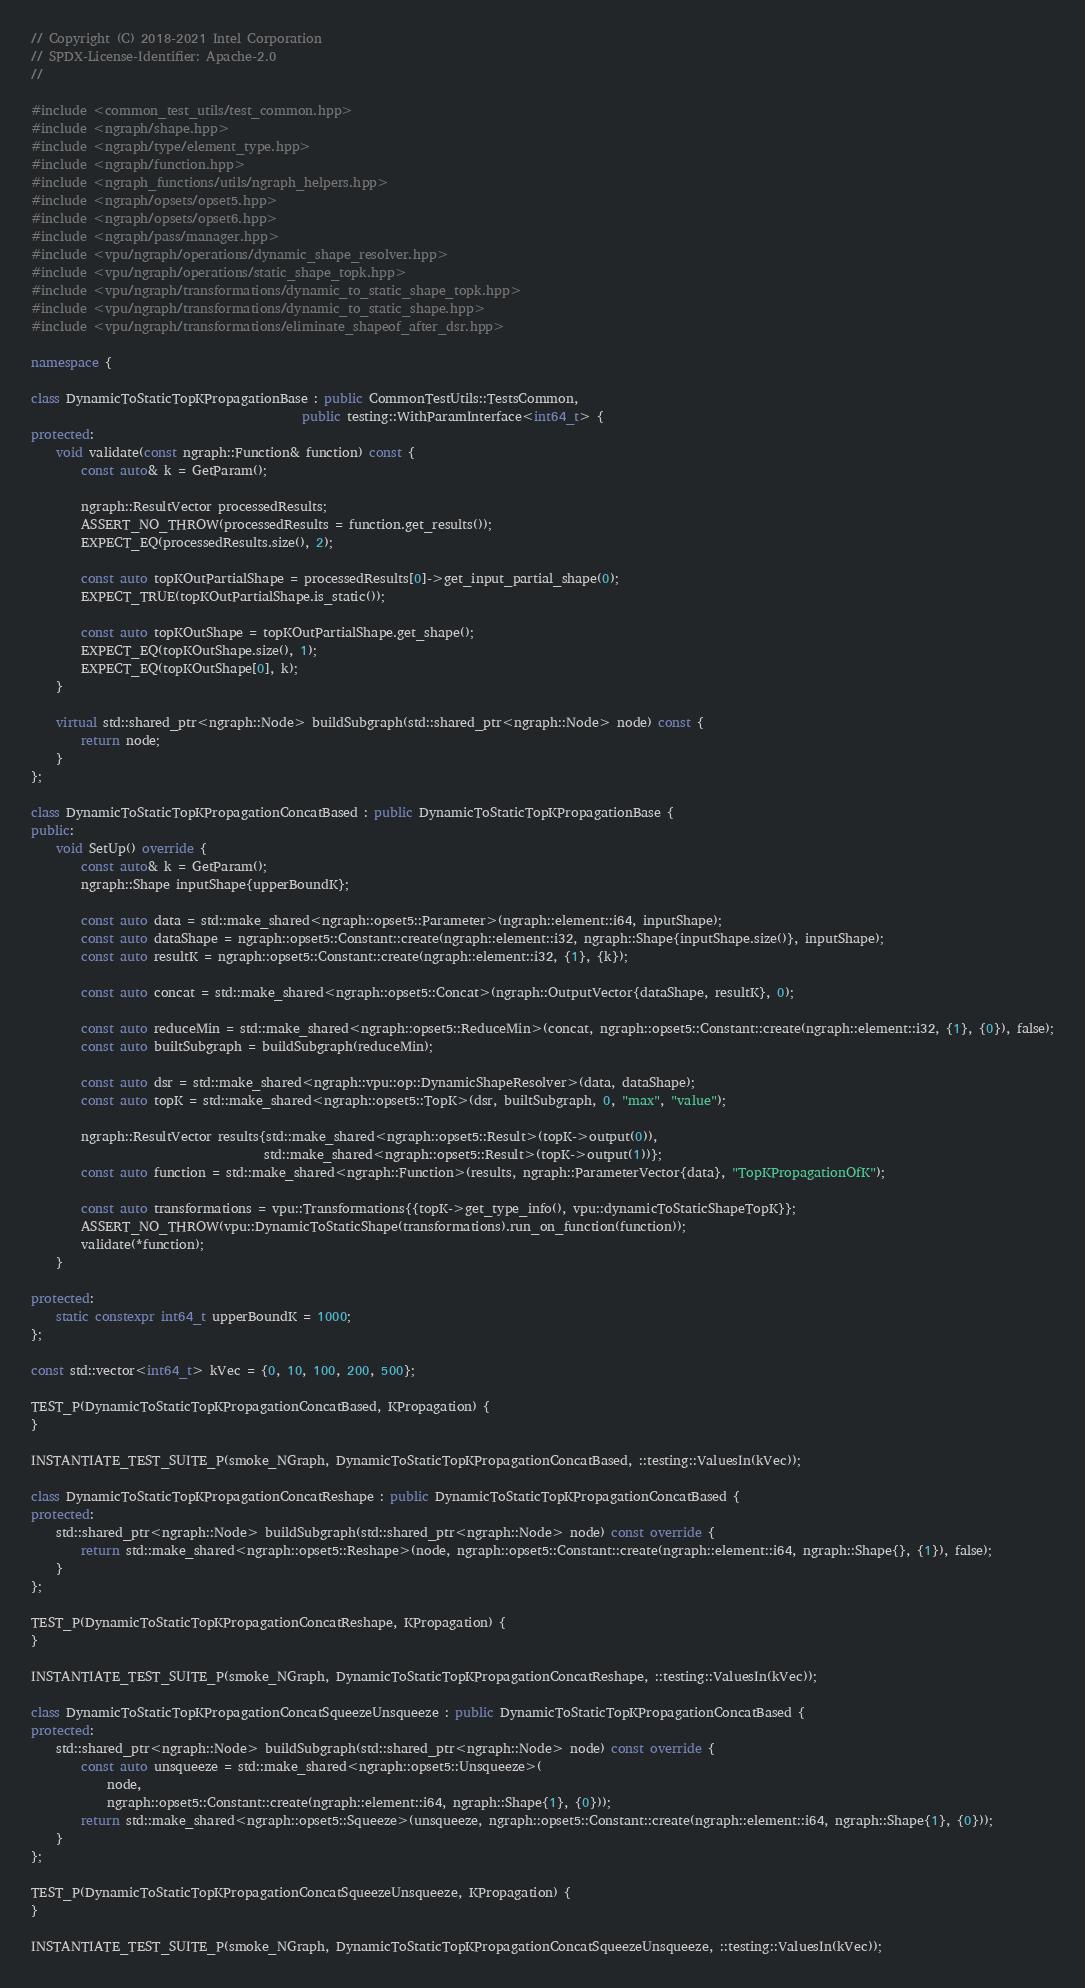Convert code to text. <code><loc_0><loc_0><loc_500><loc_500><_C++_>// Copyright (C) 2018-2021 Intel Corporation
// SPDX-License-Identifier: Apache-2.0
//

#include <common_test_utils/test_common.hpp>
#include <ngraph/shape.hpp>
#include <ngraph/type/element_type.hpp>
#include <ngraph/function.hpp>
#include <ngraph_functions/utils/ngraph_helpers.hpp>
#include <ngraph/opsets/opset5.hpp>
#include <ngraph/opsets/opset6.hpp>
#include <ngraph/pass/manager.hpp>
#include <vpu/ngraph/operations/dynamic_shape_resolver.hpp>
#include <vpu/ngraph/operations/static_shape_topk.hpp>
#include <vpu/ngraph/transformations/dynamic_to_static_shape_topk.hpp>
#include <vpu/ngraph/transformations/dynamic_to_static_shape.hpp>
#include <vpu/ngraph/transformations/eliminate_shapeof_after_dsr.hpp>

namespace {

class DynamicToStaticTopKPropagationBase : public CommonTestUtils::TestsCommon,
                                           public testing::WithParamInterface<int64_t> {
protected:
    void validate(const ngraph::Function& function) const {
        const auto& k = GetParam();

        ngraph::ResultVector processedResults;
        ASSERT_NO_THROW(processedResults = function.get_results());
        EXPECT_EQ(processedResults.size(), 2);

        const auto topKOutPartialShape = processedResults[0]->get_input_partial_shape(0);
        EXPECT_TRUE(topKOutPartialShape.is_static());

        const auto topKOutShape = topKOutPartialShape.get_shape();
        EXPECT_EQ(topKOutShape.size(), 1);
        EXPECT_EQ(topKOutShape[0], k);
    }

    virtual std::shared_ptr<ngraph::Node> buildSubgraph(std::shared_ptr<ngraph::Node> node) const {
        return node;
    }
};

class DynamicToStaticTopKPropagationConcatBased : public DynamicToStaticTopKPropagationBase {
public:
    void SetUp() override {
        const auto& k = GetParam();
        ngraph::Shape inputShape{upperBoundK};

        const auto data = std::make_shared<ngraph::opset5::Parameter>(ngraph::element::i64, inputShape);
        const auto dataShape = ngraph::opset5::Constant::create(ngraph::element::i32, ngraph::Shape{inputShape.size()}, inputShape);
        const auto resultK = ngraph::opset5::Constant::create(ngraph::element::i32, {1}, {k});

        const auto concat = std::make_shared<ngraph::opset5::Concat>(ngraph::OutputVector{dataShape, resultK}, 0);

        const auto reduceMin = std::make_shared<ngraph::opset5::ReduceMin>(concat, ngraph::opset5::Constant::create(ngraph::element::i32, {1}, {0}), false);
        const auto builtSubgraph = buildSubgraph(reduceMin);

        const auto dsr = std::make_shared<ngraph::vpu::op::DynamicShapeResolver>(data, dataShape);
        const auto topK = std::make_shared<ngraph::opset5::TopK>(dsr, builtSubgraph, 0, "max", "value");

        ngraph::ResultVector results{std::make_shared<ngraph::opset5::Result>(topK->output(0)),
                                     std::make_shared<ngraph::opset5::Result>(topK->output(1))};
        const auto function = std::make_shared<ngraph::Function>(results, ngraph::ParameterVector{data}, "TopKPropagationOfK");

        const auto transformations = vpu::Transformations{{topK->get_type_info(), vpu::dynamicToStaticShapeTopK}};
        ASSERT_NO_THROW(vpu::DynamicToStaticShape(transformations).run_on_function(function));
        validate(*function);
    }

protected:
    static constexpr int64_t upperBoundK = 1000;
};

const std::vector<int64_t> kVec = {0, 10, 100, 200, 500};

TEST_P(DynamicToStaticTopKPropagationConcatBased, KPropagation) {
}

INSTANTIATE_TEST_SUITE_P(smoke_NGraph, DynamicToStaticTopKPropagationConcatBased, ::testing::ValuesIn(kVec));

class DynamicToStaticTopKPropagationConcatReshape : public DynamicToStaticTopKPropagationConcatBased {
protected:
    std::shared_ptr<ngraph::Node> buildSubgraph(std::shared_ptr<ngraph::Node> node) const override {
        return std::make_shared<ngraph::opset5::Reshape>(node, ngraph::opset5::Constant::create(ngraph::element::i64, ngraph::Shape{}, {1}), false);
    }
};

TEST_P(DynamicToStaticTopKPropagationConcatReshape, KPropagation) {
}

INSTANTIATE_TEST_SUITE_P(smoke_NGraph, DynamicToStaticTopKPropagationConcatReshape, ::testing::ValuesIn(kVec));

class DynamicToStaticTopKPropagationConcatSqueezeUnsqueeze : public DynamicToStaticTopKPropagationConcatBased {
protected:
    std::shared_ptr<ngraph::Node> buildSubgraph(std::shared_ptr<ngraph::Node> node) const override {
        const auto unsqueeze = std::make_shared<ngraph::opset5::Unsqueeze>(
            node,
            ngraph::opset5::Constant::create(ngraph::element::i64, ngraph::Shape{1}, {0}));
        return std::make_shared<ngraph::opset5::Squeeze>(unsqueeze, ngraph::opset5::Constant::create(ngraph::element::i64, ngraph::Shape{1}, {0}));
    }
};

TEST_P(DynamicToStaticTopKPropagationConcatSqueezeUnsqueeze, KPropagation) {
}

INSTANTIATE_TEST_SUITE_P(smoke_NGraph, DynamicToStaticTopKPropagationConcatSqueezeUnsqueeze, ::testing::ValuesIn(kVec));
</code> 